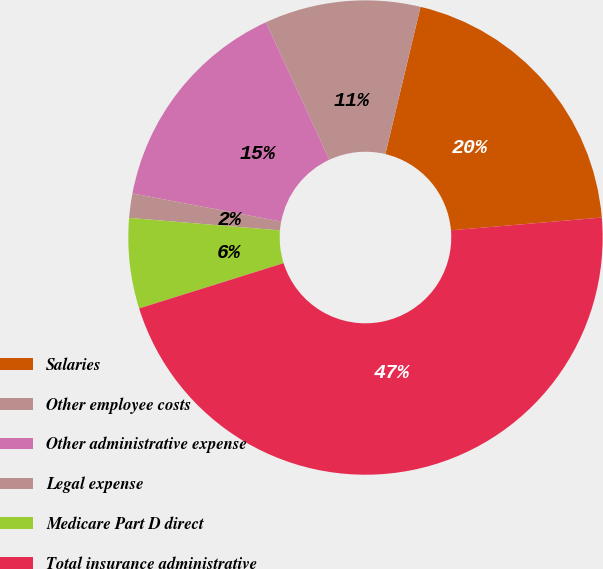Convert chart. <chart><loc_0><loc_0><loc_500><loc_500><pie_chart><fcel>Salaries<fcel>Other employee costs<fcel>Other administrative expense<fcel>Legal expense<fcel>Medicare Part D direct<fcel>Total insurance administrative<nl><fcel>19.93%<fcel>10.63%<fcel>15.12%<fcel>1.66%<fcel>6.15%<fcel>46.51%<nl></chart> 